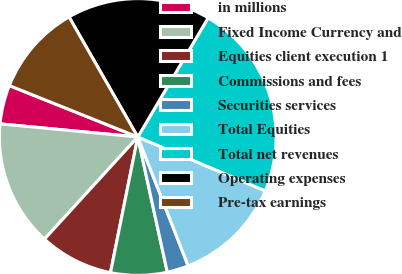<chart> <loc_0><loc_0><loc_500><loc_500><pie_chart><fcel>in millions<fcel>Fixed Income Currency and<fcel>Equities client execution 1<fcel>Commissions and fees<fcel>Securities services<fcel>Total Equities<fcel>Total net revenues<fcel>Operating expenses<fcel>Pre-tax earnings<nl><fcel>4.55%<fcel>14.73%<fcel>8.62%<fcel>6.58%<fcel>2.51%<fcel>12.7%<fcel>22.88%<fcel>16.77%<fcel>10.66%<nl></chart> 